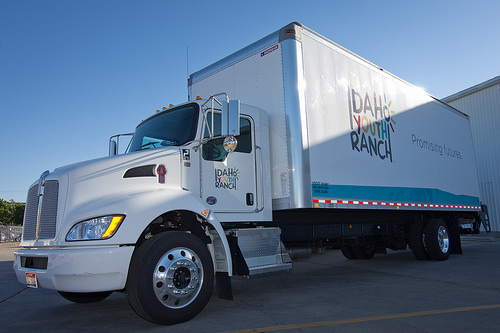<image>
Can you confirm if the truck is on the road? Yes. Looking at the image, I can see the truck is positioned on top of the road, with the road providing support. Is the tire in front of the truck? No. The tire is not in front of the truck. The spatial positioning shows a different relationship between these objects. 